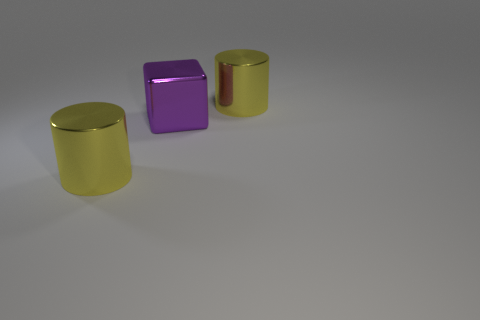Add 2 large purple shiny blocks. How many objects exist? 5 Subtract 0 gray blocks. How many objects are left? 3 Subtract all cylinders. How many objects are left? 1 Subtract all large yellow metal objects. Subtract all big shiny cubes. How many objects are left? 0 Add 1 purple objects. How many purple objects are left? 2 Add 2 big metal blocks. How many big metal blocks exist? 3 